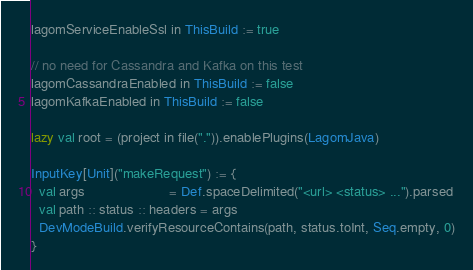<code> <loc_0><loc_0><loc_500><loc_500><_Scala_>lagomServiceEnableSsl in ThisBuild := true

// no need for Cassandra and Kafka on this test
lagomCassandraEnabled in ThisBuild := false
lagomKafkaEnabled in ThisBuild := false

lazy val root = (project in file(".")).enablePlugins(LagomJava)

InputKey[Unit]("makeRequest") := {
  val args                      = Def.spaceDelimited("<url> <status> ...").parsed
  val path :: status :: headers = args
  DevModeBuild.verifyResourceContains(path, status.toInt, Seq.empty, 0)
}
</code> 